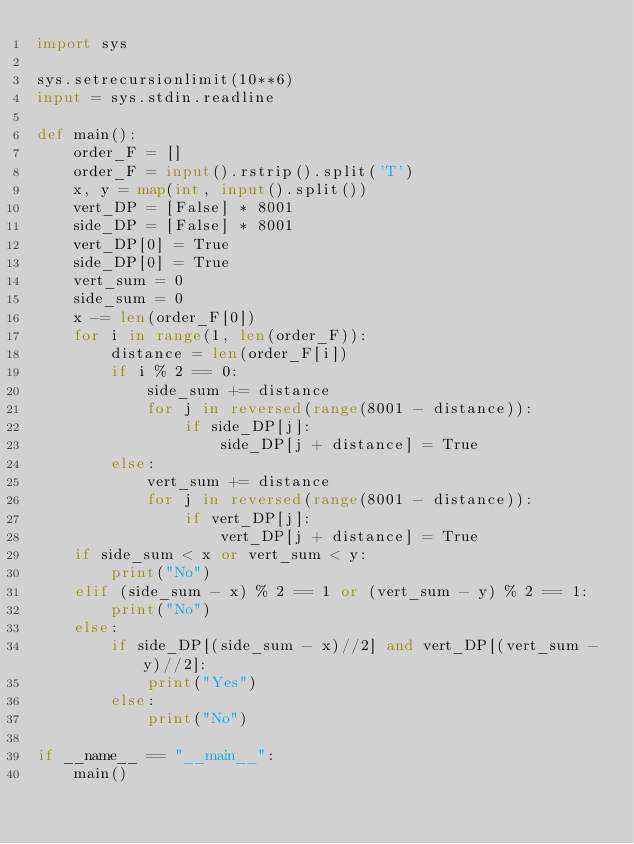Convert code to text. <code><loc_0><loc_0><loc_500><loc_500><_Python_>import sys

sys.setrecursionlimit(10**6)
input = sys.stdin.readline

def main():
    order_F = []
    order_F = input().rstrip().split('T')
    x, y = map(int, input().split())
    vert_DP = [False] * 8001
    side_DP = [False] * 8001
    vert_DP[0] = True
    side_DP[0] = True
    vert_sum = 0
    side_sum = 0
    x -= len(order_F[0])
    for i in range(1, len(order_F)):
        distance = len(order_F[i])
        if i % 2 == 0:
            side_sum += distance
            for j in reversed(range(8001 - distance)):
                if side_DP[j]:
                    side_DP[j + distance] = True
        else:
            vert_sum += distance
            for j in reversed(range(8001 - distance)):
                if vert_DP[j]:
                    vert_DP[j + distance] = True
    if side_sum < x or vert_sum < y:
        print("No")
    elif (side_sum - x) % 2 == 1 or (vert_sum - y) % 2 == 1:
        print("No")
    else:
        if side_DP[(side_sum - x)//2] and vert_DP[(vert_sum - y)//2]:
            print("Yes")
        else:
            print("No")

if __name__ == "__main__":
    main()</code> 